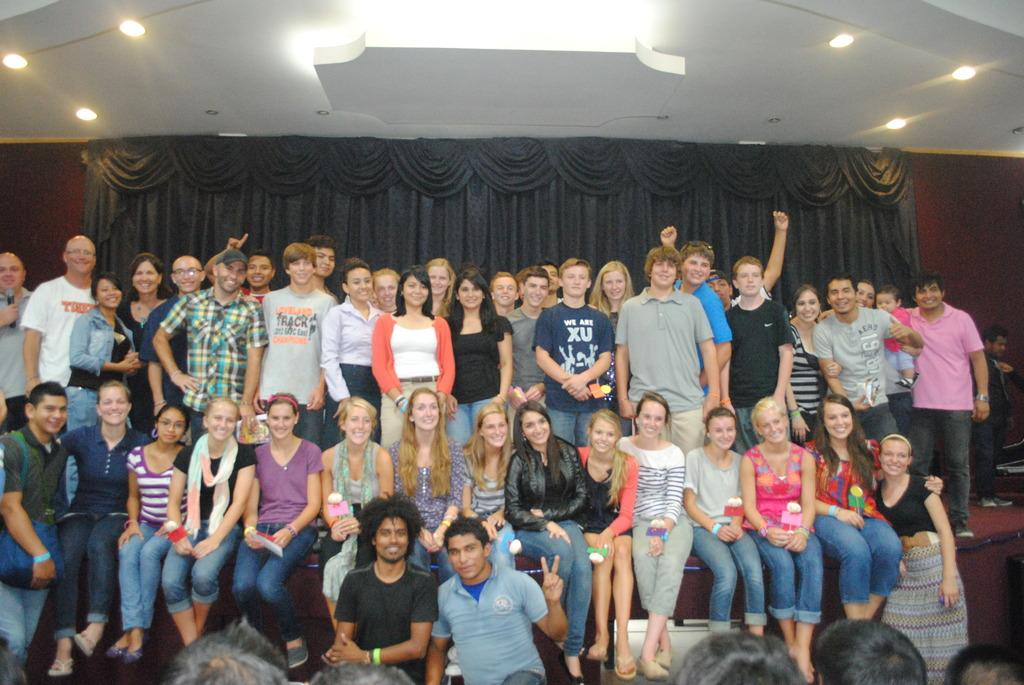How many people are in the image? There is a group of people in the image, but the exact number is not specified. What are the people wearing? The people in the image are wearing clothes. What can be seen in the middle of the image? There are curtains in the middle of the image. What type of lighting is present in the image? There are lights on the ceiling in the image. Where is the ceiling located in the image? The ceiling is at the top of the image. What time is shown on the clock in the image? There is no clock present in the image, so it is not possible to determine the time. 